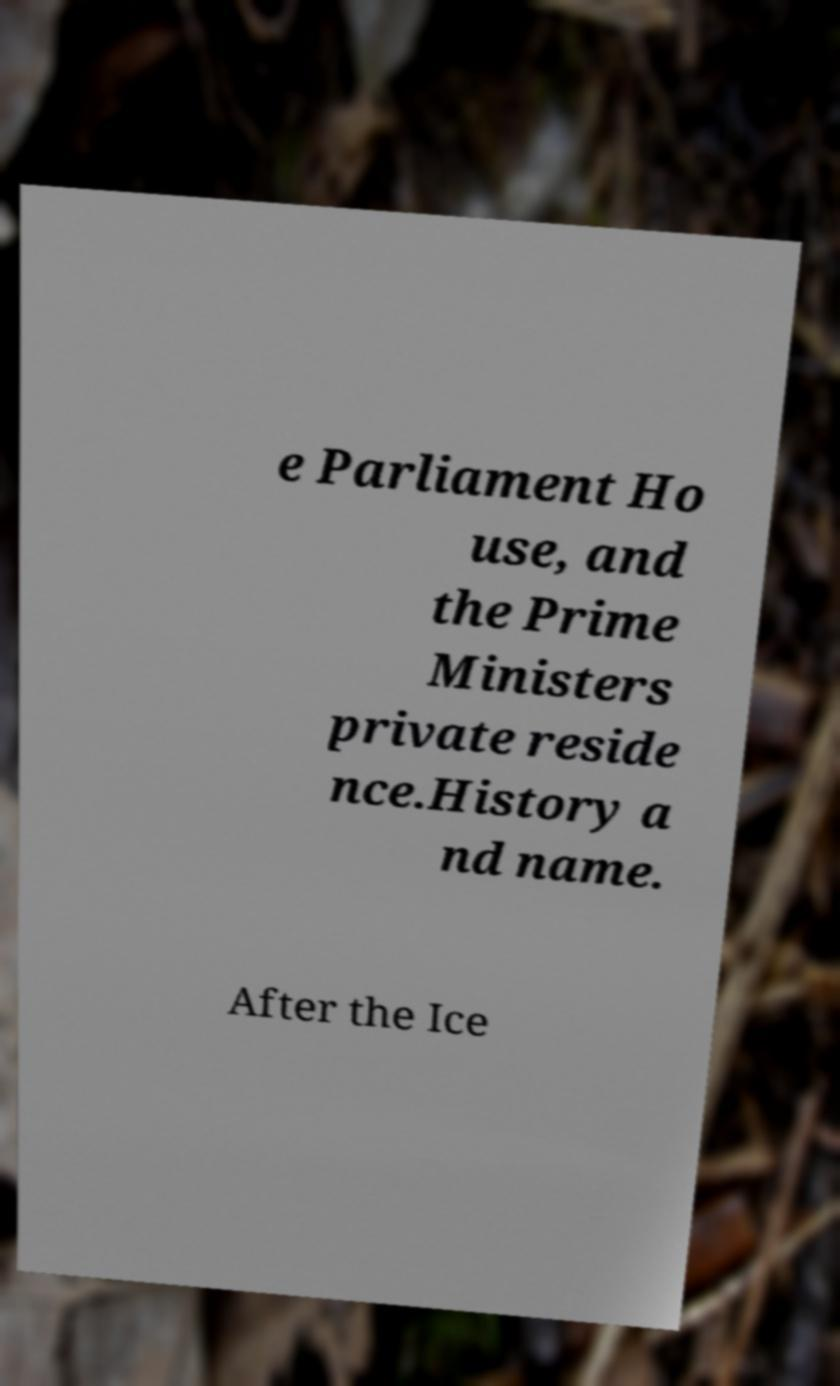For documentation purposes, I need the text within this image transcribed. Could you provide that? e Parliament Ho use, and the Prime Ministers private reside nce.History a nd name. After the Ice 